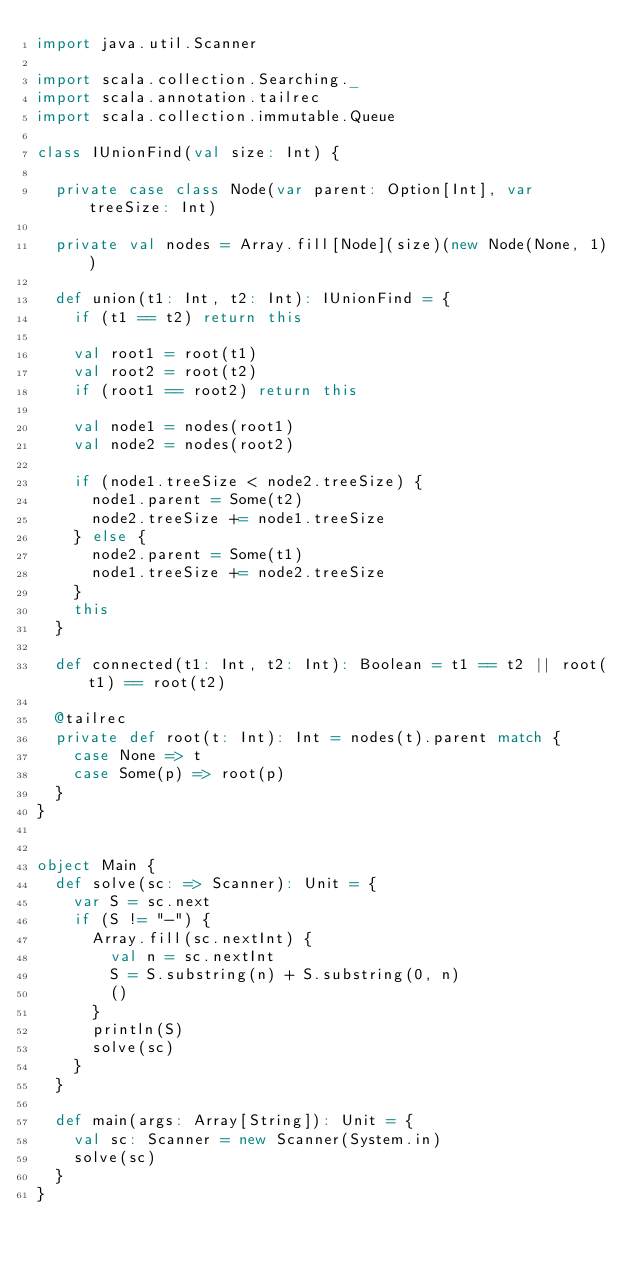<code> <loc_0><loc_0><loc_500><loc_500><_Scala_>import java.util.Scanner

import scala.collection.Searching._
import scala.annotation.tailrec
import scala.collection.immutable.Queue

class IUnionFind(val size: Int) {

  private case class Node(var parent: Option[Int], var treeSize: Int)

  private val nodes = Array.fill[Node](size)(new Node(None, 1))

  def union(t1: Int, t2: Int): IUnionFind = {
    if (t1 == t2) return this

    val root1 = root(t1)
    val root2 = root(t2)
    if (root1 == root2) return this

    val node1 = nodes(root1)
    val node2 = nodes(root2)

    if (node1.treeSize < node2.treeSize) {
      node1.parent = Some(t2)
      node2.treeSize += node1.treeSize
    } else {
      node2.parent = Some(t1)
      node1.treeSize += node2.treeSize
    }
    this
  }

  def connected(t1: Int, t2: Int): Boolean = t1 == t2 || root(t1) == root(t2)

  @tailrec
  private def root(t: Int): Int = nodes(t).parent match {
    case None => t
    case Some(p) => root(p)
  }
}


object Main {
  def solve(sc: => Scanner): Unit = {
    var S = sc.next
    if (S != "-") {
      Array.fill(sc.nextInt) {
        val n = sc.nextInt
        S = S.substring(n) + S.substring(0, n)
        ()
      }
      println(S)
      solve(sc)
    }
  }

  def main(args: Array[String]): Unit = {
    val sc: Scanner = new Scanner(System.in)
    solve(sc)
  }
}


</code> 